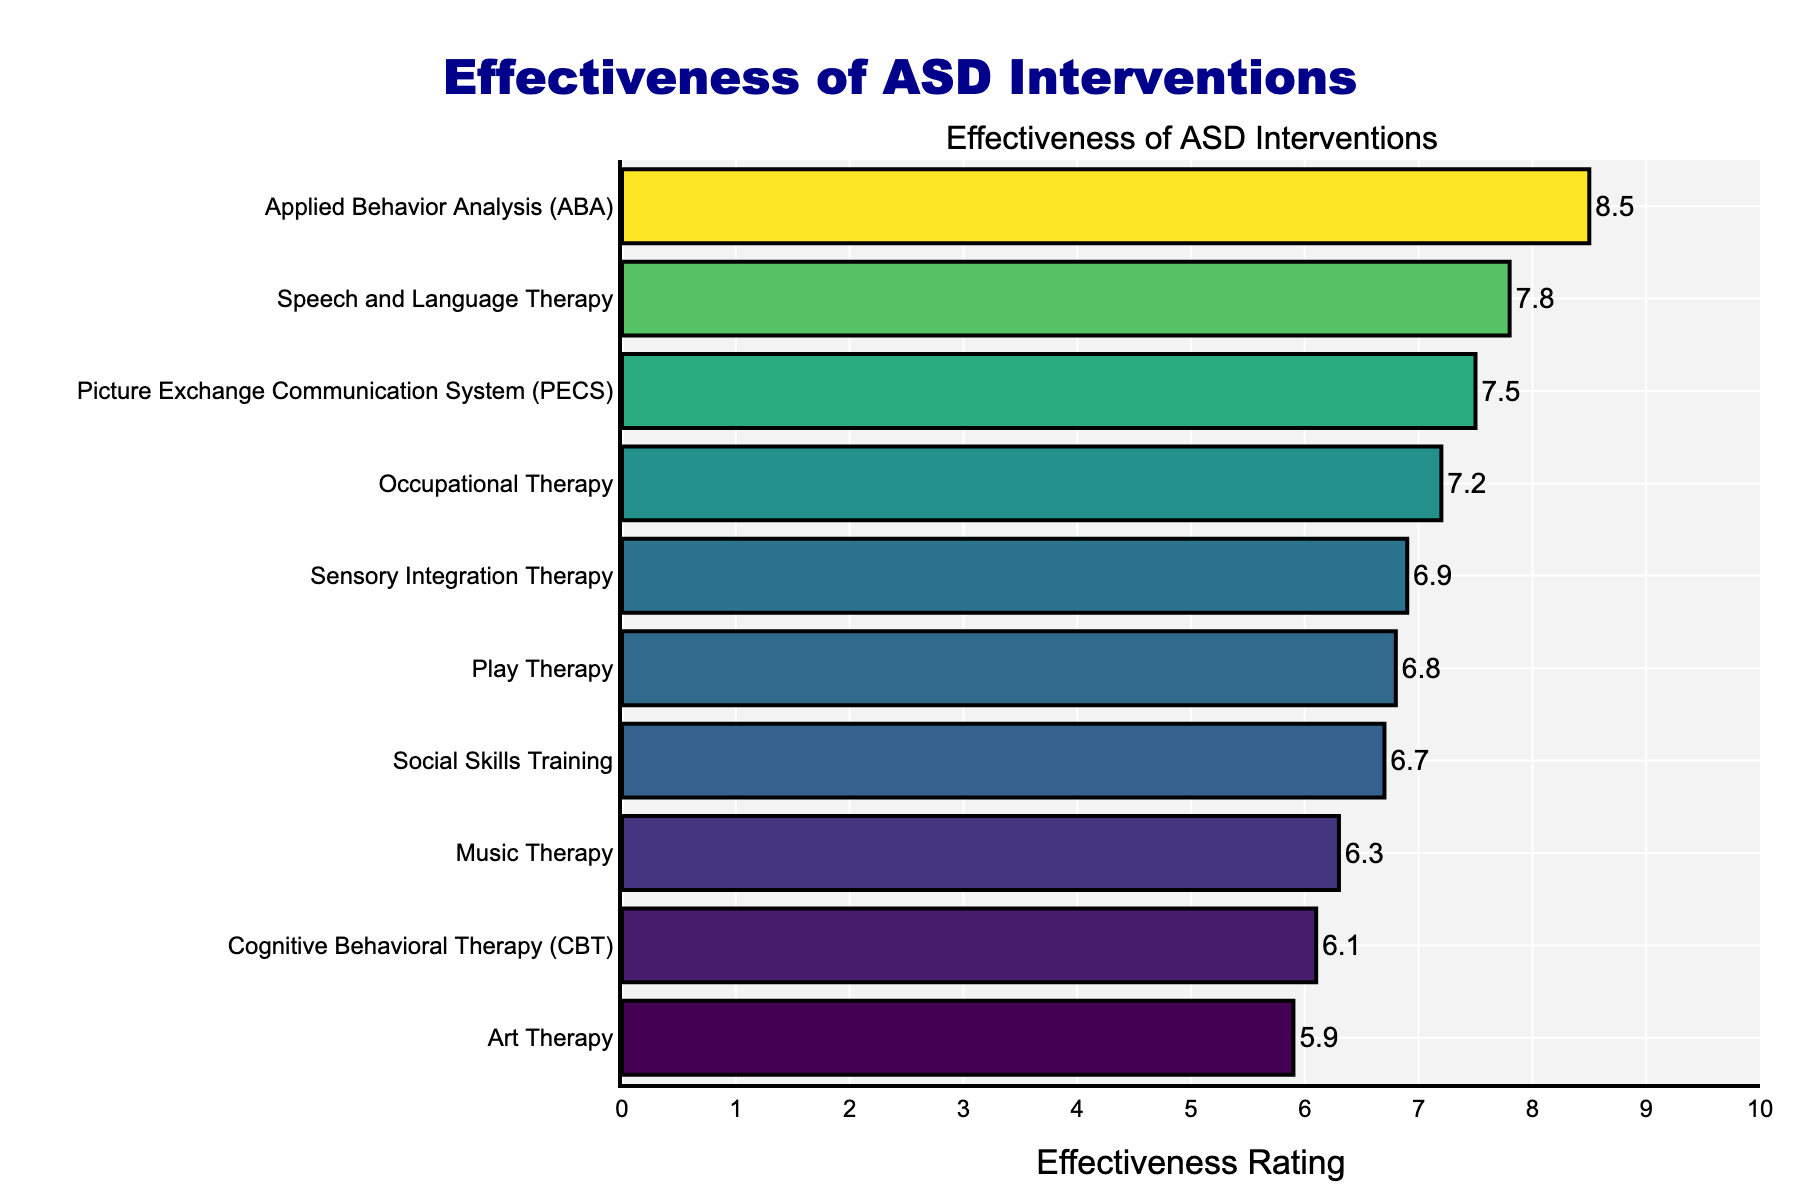What is the title of the plot? The title is written at the top of the figure and describes its overall content.
Answer: Effectiveness of ASD Interventions How many different types of interventions are shown in the plot? Each bar represents one type of intervention, and we can count the bars to find the total number of interventions displayed.
Answer: 10 Which intervention has the highest effectiveness rating? By looking for the longest bar (to the rightmost point), we can find the intervention with the highest effectiveness rating.
Answer: Applied Behavior Analysis (ABA) Which intervention has the lowest effectiveness rating? The shortest bar (towards the leftmost point) will indicate the intervention with the lowest effectiveness rating.
Answer: Art Therapy What is the effectiveness rating of Cognitive Behavioral Therapy (CBT)? Locate the bar corresponding to Cognitive Behavioral Therapy (CBT) and read the label at the end of the bar.
Answer: 6.1 What is the difference in effectiveness rating between Speech and Language Therapy and Music Therapy? Identify the effectiveness ratings for both interventions and subtract the smaller rating from the larger one: 7.8 (Speech and Language Therapy) - 6.3 (Music Therapy)
Answer: 1.5 List all interventions with an effectiveness rating greater than 7. Check each bar and note down those which extend beyond the 7 mark on the x-axis.
Answer: Applied Behavior Analysis (ABA), Occupational Therapy, Speech and Language Therapy, Picture Exchange Communication System (PECS) What is the average effectiveness rating of all interventions? Sum all the effectiveness ratings and divide by the number of interventions: (8.5 + 7.2 + 7.8 + 6.9 + 7.5 + 6.7 + 6.3 + 5.9 + 6.8 + 6.1) / 10
Answer: 6.97 Is there an intervention with an effectiveness rating close to 7? Look for bars whose labels are close to the rating of 7.
Answer: Sensory Integration Therapy (6.9), Social Skills Training (6.7), Play Therapy (6.8) Which interventions are rated lower than Social Skills Training? Identify the rating of Social Skills Training (6.7) and list all interventions with lower ratings than this.
Answer: Music Therapy, Art Therapy, Cognitive Behavioral Therapy (CBT) 